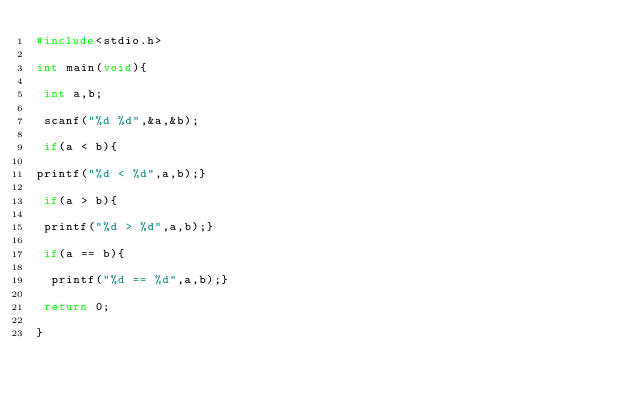Convert code to text. <code><loc_0><loc_0><loc_500><loc_500><_C_>#include<stdio.h>

int main(void){

 int a,b;

 scanf("%d %d",&a,&b); 

 if(a < b){   

printf("%d < %d",a,b);}

 if(a > b){  

 printf("%d > %d",a,b);}

 if(a == b){ 

  printf("%d == %d",a,b);} 

 return 0;

} </code> 